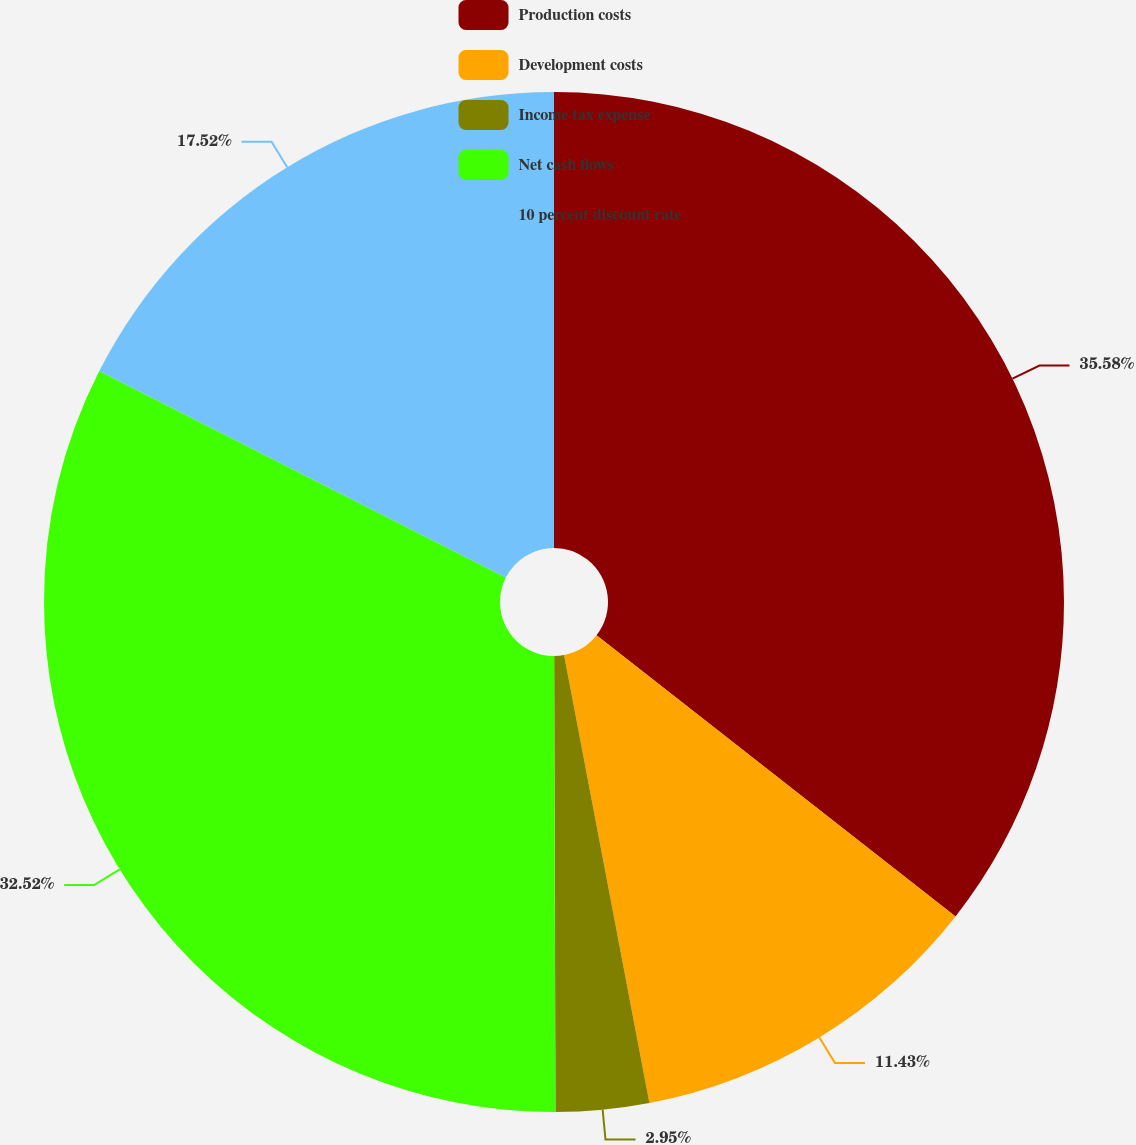Convert chart to OTSL. <chart><loc_0><loc_0><loc_500><loc_500><pie_chart><fcel>Production costs<fcel>Development costs<fcel>Income tax expense<fcel>Net cash flows<fcel>10 percent discount rate<nl><fcel>35.57%<fcel>11.43%<fcel>2.95%<fcel>32.52%<fcel>17.52%<nl></chart> 